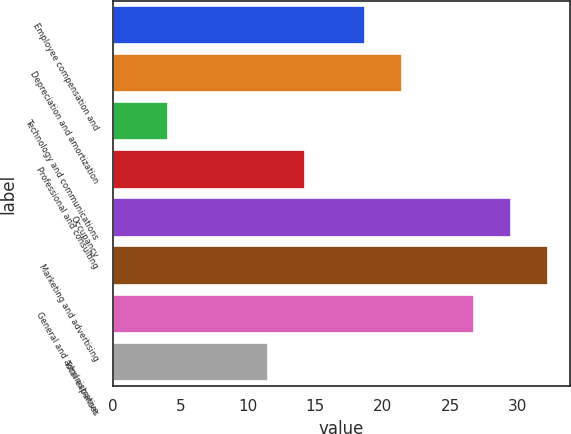<chart> <loc_0><loc_0><loc_500><loc_500><bar_chart><fcel>Employee compensation and<fcel>Depreciation and amortization<fcel>Technology and communications<fcel>Professional and consulting<fcel>Occupancy<fcel>Marketing and advertising<fcel>General and administrative<fcel>Total expenses<nl><fcel>18.7<fcel>21.44<fcel>4.1<fcel>14.24<fcel>29.54<fcel>32.28<fcel>26.8<fcel>11.5<nl></chart> 